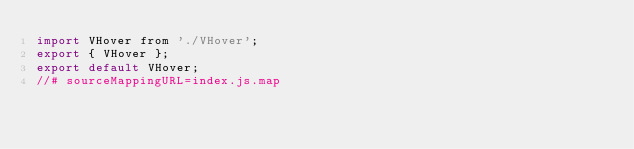<code> <loc_0><loc_0><loc_500><loc_500><_JavaScript_>import VHover from './VHover';
export { VHover };
export default VHover;
//# sourceMappingURL=index.js.map</code> 